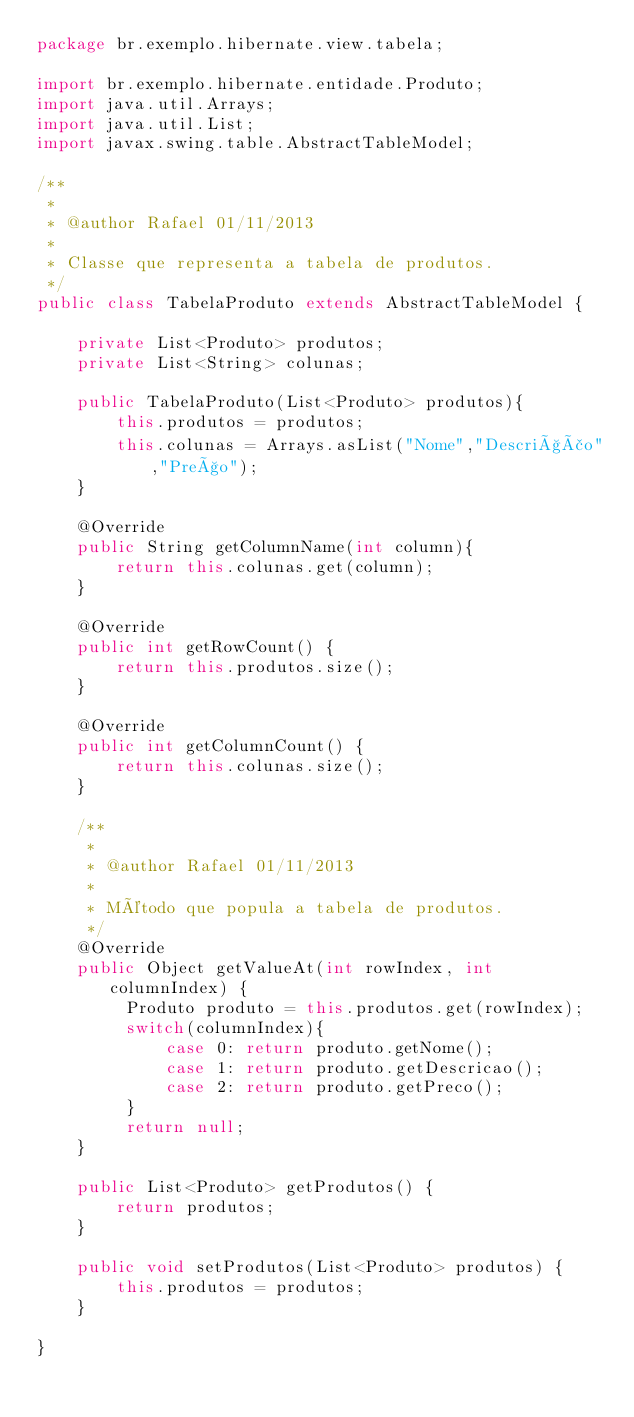Convert code to text. <code><loc_0><loc_0><loc_500><loc_500><_Java_>package br.exemplo.hibernate.view.tabela;

import br.exemplo.hibernate.entidade.Produto;
import java.util.Arrays;
import java.util.List;
import javax.swing.table.AbstractTableModel;

/**
 *
 * @author Rafael 01/11/2013
 * 
 * Classe que representa a tabela de produtos.
 */
public class TabelaProduto extends AbstractTableModel {

    private List<Produto> produtos;
    private List<String> colunas;
    
    public TabelaProduto(List<Produto> produtos){
        this.produtos = produtos;
        this.colunas = Arrays.asList("Nome","Descrição","Preço");
    }
    
    @Override
    public String getColumnName(int column){
        return this.colunas.get(column);
    }
    
    @Override
    public int getRowCount() {
        return this.produtos.size();
    }

    @Override
    public int getColumnCount() {
        return this.colunas.size();
    }

    /**
     *
     * @author Rafael 01/11/2013
     * 
     * Método que popula a tabela de produtos.
     */ 
    @Override
    public Object getValueAt(int rowIndex, int columnIndex) {
         Produto produto = this.produtos.get(rowIndex);
         switch(columnIndex){
             case 0: return produto.getNome();
             case 1: return produto.getDescricao();
             case 2: return produto.getPreco();
         }
         return null;
    }

    public List<Produto> getProdutos() {
        return produtos;
    }

    public void setProdutos(List<Produto> produtos) {
        this.produtos = produtos;
    }
    
}
</code> 